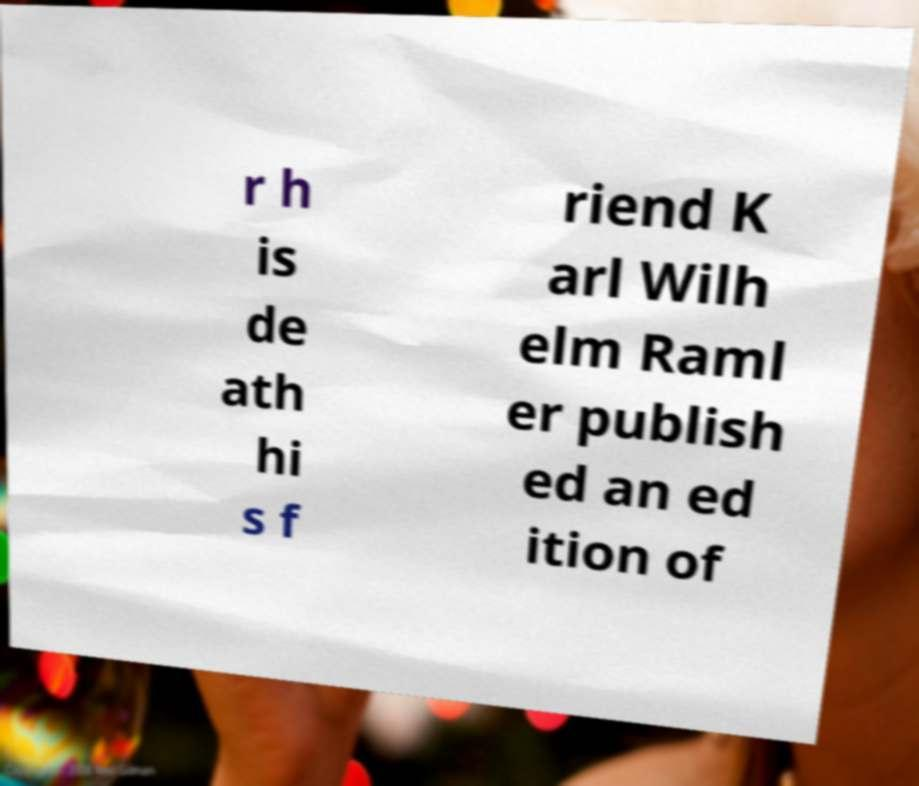Can you read and provide the text displayed in the image?This photo seems to have some interesting text. Can you extract and type it out for me? r h is de ath hi s f riend K arl Wilh elm Raml er publish ed an ed ition of 